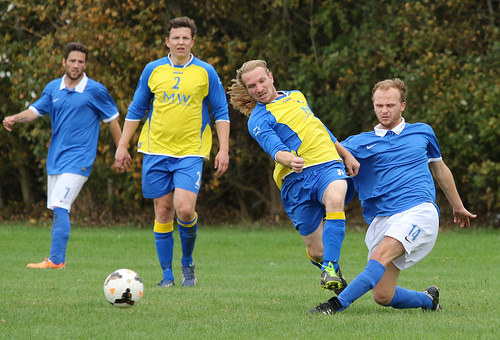<image>
Is there a ball in the man? No. The ball is not contained within the man. These objects have a different spatial relationship. 